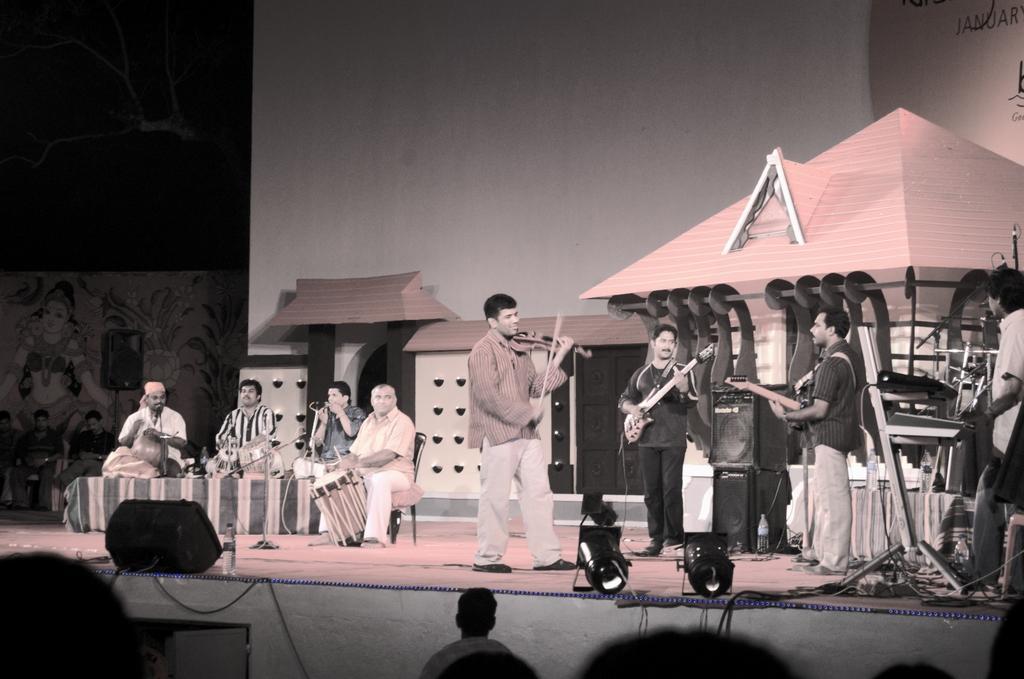How would you summarize this image in a sentence or two? In this image, There are some people standing in the right side they are holding some music instruments, In the left side there are some people sitting and holding some music instruments, In the background there is a white color wall and there is a shed in pink color. 